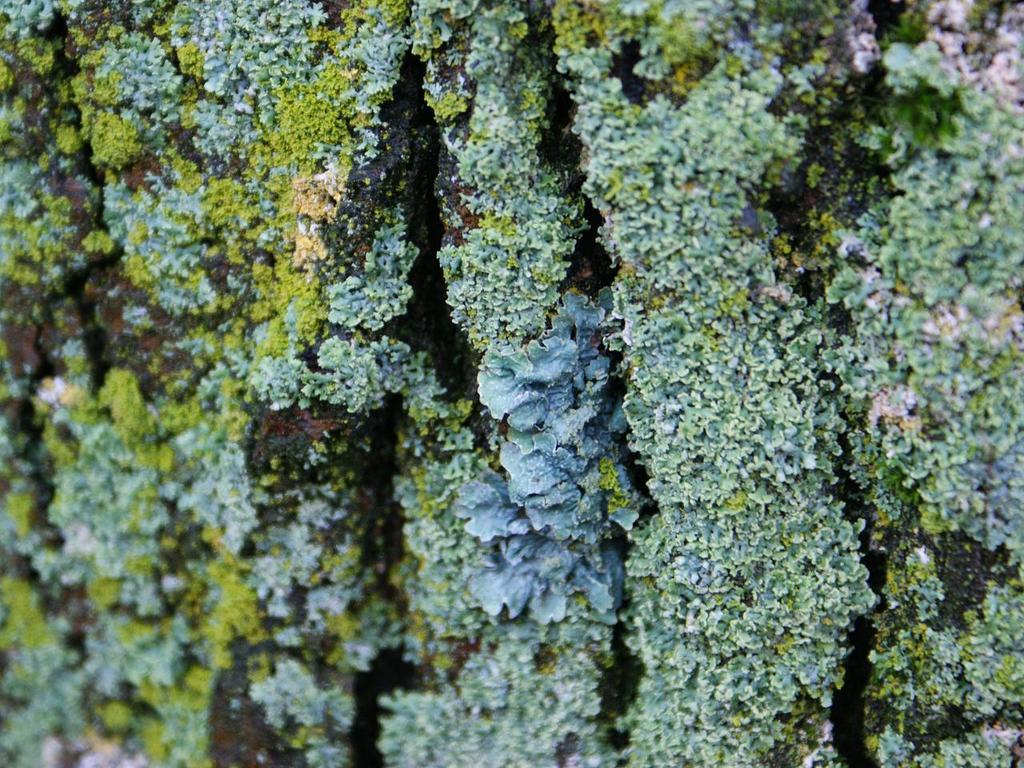What type of vegetation can be seen in the image? There is moss in the image. How many men can be seen interacting with the moss in the image? There are no men present in the image; it only features moss. What role does the father play in the image? There is no father present in the image; it only features moss. 